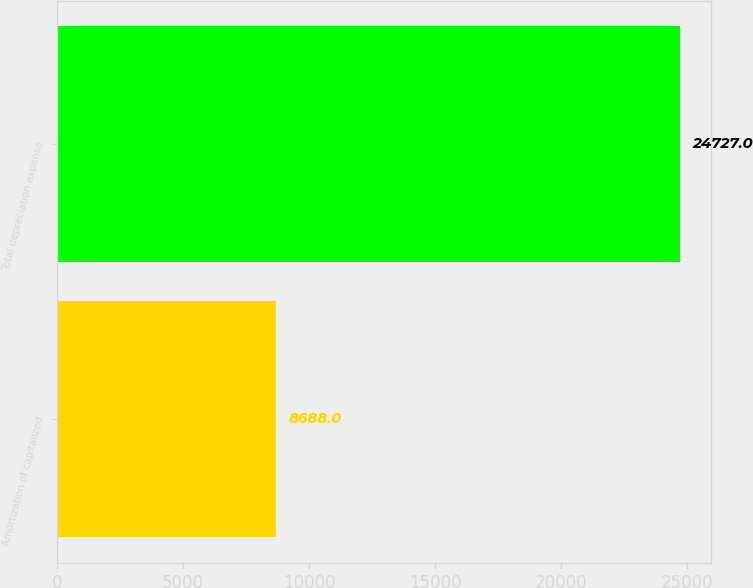Convert chart. <chart><loc_0><loc_0><loc_500><loc_500><bar_chart><fcel>Amortization of capitalized<fcel>Total depreciation expense<nl><fcel>8688<fcel>24727<nl></chart> 